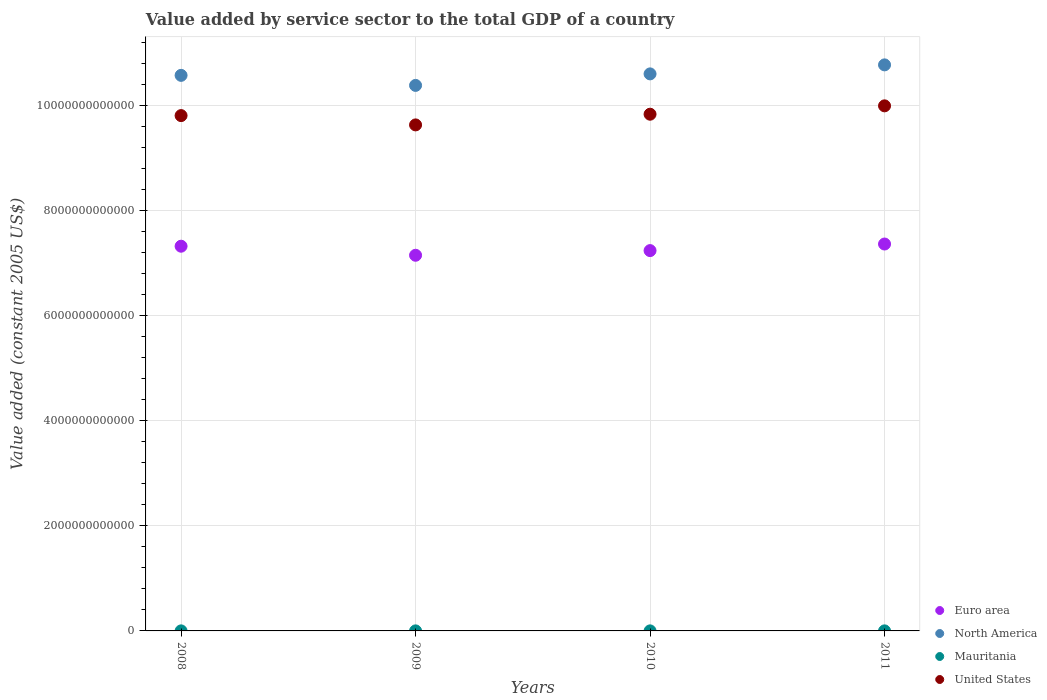What is the value added by service sector in Mauritania in 2010?
Keep it short and to the point. 9.63e+08. Across all years, what is the maximum value added by service sector in United States?
Make the answer very short. 1.00e+13. Across all years, what is the minimum value added by service sector in Euro area?
Offer a very short reply. 7.15e+12. In which year was the value added by service sector in United States maximum?
Your response must be concise. 2011. What is the total value added by service sector in North America in the graph?
Give a very brief answer. 4.23e+13. What is the difference between the value added by service sector in Mauritania in 2008 and that in 2009?
Ensure brevity in your answer.  -5.03e+06. What is the difference between the value added by service sector in Mauritania in 2011 and the value added by service sector in United States in 2009?
Provide a short and direct response. -9.63e+12. What is the average value added by service sector in United States per year?
Provide a succinct answer. 9.82e+12. In the year 2008, what is the difference between the value added by service sector in Mauritania and value added by service sector in North America?
Offer a terse response. -1.06e+13. What is the ratio of the value added by service sector in North America in 2008 to that in 2011?
Give a very brief answer. 0.98. Is the value added by service sector in North America in 2008 less than that in 2009?
Provide a short and direct response. No. What is the difference between the highest and the second highest value added by service sector in Mauritania?
Make the answer very short. 5.58e+07. What is the difference between the highest and the lowest value added by service sector in United States?
Give a very brief answer. 3.63e+11. Is it the case that in every year, the sum of the value added by service sector in North America and value added by service sector in Mauritania  is greater than the value added by service sector in Euro area?
Give a very brief answer. Yes. Is the value added by service sector in Mauritania strictly less than the value added by service sector in United States over the years?
Offer a terse response. Yes. What is the difference between two consecutive major ticks on the Y-axis?
Provide a succinct answer. 2.00e+12. Does the graph contain any zero values?
Offer a very short reply. No. Does the graph contain grids?
Your answer should be very brief. Yes. Where does the legend appear in the graph?
Make the answer very short. Bottom right. How many legend labels are there?
Your answer should be very brief. 4. What is the title of the graph?
Your response must be concise. Value added by service sector to the total GDP of a country. What is the label or title of the Y-axis?
Offer a terse response. Value added (constant 2005 US$). What is the Value added (constant 2005 US$) in Euro area in 2008?
Your answer should be very brief. 7.32e+12. What is the Value added (constant 2005 US$) in North America in 2008?
Ensure brevity in your answer.  1.06e+13. What is the Value added (constant 2005 US$) of Mauritania in 2008?
Offer a terse response. 9.01e+08. What is the Value added (constant 2005 US$) in United States in 2008?
Give a very brief answer. 9.81e+12. What is the Value added (constant 2005 US$) of Euro area in 2009?
Ensure brevity in your answer.  7.15e+12. What is the Value added (constant 2005 US$) of North America in 2009?
Your answer should be compact. 1.04e+13. What is the Value added (constant 2005 US$) of Mauritania in 2009?
Your answer should be very brief. 9.06e+08. What is the Value added (constant 2005 US$) in United States in 2009?
Provide a short and direct response. 9.63e+12. What is the Value added (constant 2005 US$) in Euro area in 2010?
Your response must be concise. 7.24e+12. What is the Value added (constant 2005 US$) of North America in 2010?
Offer a very short reply. 1.06e+13. What is the Value added (constant 2005 US$) in Mauritania in 2010?
Offer a terse response. 9.63e+08. What is the Value added (constant 2005 US$) of United States in 2010?
Provide a succinct answer. 9.84e+12. What is the Value added (constant 2005 US$) of Euro area in 2011?
Keep it short and to the point. 7.37e+12. What is the Value added (constant 2005 US$) of North America in 2011?
Provide a succinct answer. 1.08e+13. What is the Value added (constant 2005 US$) of Mauritania in 2011?
Offer a terse response. 1.02e+09. What is the Value added (constant 2005 US$) in United States in 2011?
Provide a short and direct response. 1.00e+13. Across all years, what is the maximum Value added (constant 2005 US$) in Euro area?
Offer a terse response. 7.37e+12. Across all years, what is the maximum Value added (constant 2005 US$) of North America?
Make the answer very short. 1.08e+13. Across all years, what is the maximum Value added (constant 2005 US$) in Mauritania?
Provide a succinct answer. 1.02e+09. Across all years, what is the maximum Value added (constant 2005 US$) in United States?
Make the answer very short. 1.00e+13. Across all years, what is the minimum Value added (constant 2005 US$) in Euro area?
Your answer should be very brief. 7.15e+12. Across all years, what is the minimum Value added (constant 2005 US$) in North America?
Your answer should be compact. 1.04e+13. Across all years, what is the minimum Value added (constant 2005 US$) in Mauritania?
Your response must be concise. 9.01e+08. Across all years, what is the minimum Value added (constant 2005 US$) of United States?
Offer a terse response. 9.63e+12. What is the total Value added (constant 2005 US$) in Euro area in the graph?
Your response must be concise. 2.91e+13. What is the total Value added (constant 2005 US$) in North America in the graph?
Your answer should be very brief. 4.23e+13. What is the total Value added (constant 2005 US$) in Mauritania in the graph?
Your answer should be very brief. 3.79e+09. What is the total Value added (constant 2005 US$) of United States in the graph?
Provide a succinct answer. 3.93e+13. What is the difference between the Value added (constant 2005 US$) of Euro area in 2008 and that in 2009?
Provide a short and direct response. 1.72e+11. What is the difference between the Value added (constant 2005 US$) of North America in 2008 and that in 2009?
Give a very brief answer. 1.91e+11. What is the difference between the Value added (constant 2005 US$) of Mauritania in 2008 and that in 2009?
Give a very brief answer. -5.03e+06. What is the difference between the Value added (constant 2005 US$) of United States in 2008 and that in 2009?
Ensure brevity in your answer.  1.77e+11. What is the difference between the Value added (constant 2005 US$) of Euro area in 2008 and that in 2010?
Ensure brevity in your answer.  8.37e+1. What is the difference between the Value added (constant 2005 US$) of North America in 2008 and that in 2010?
Ensure brevity in your answer.  -2.81e+1. What is the difference between the Value added (constant 2005 US$) in Mauritania in 2008 and that in 2010?
Give a very brief answer. -6.13e+07. What is the difference between the Value added (constant 2005 US$) in United States in 2008 and that in 2010?
Provide a short and direct response. -2.64e+1. What is the difference between the Value added (constant 2005 US$) of Euro area in 2008 and that in 2011?
Keep it short and to the point. -4.16e+1. What is the difference between the Value added (constant 2005 US$) in North America in 2008 and that in 2011?
Your answer should be compact. -2.00e+11. What is the difference between the Value added (constant 2005 US$) in Mauritania in 2008 and that in 2011?
Your answer should be very brief. -1.17e+08. What is the difference between the Value added (constant 2005 US$) of United States in 2008 and that in 2011?
Offer a terse response. -1.86e+11. What is the difference between the Value added (constant 2005 US$) in Euro area in 2009 and that in 2010?
Your answer should be compact. -8.87e+1. What is the difference between the Value added (constant 2005 US$) of North America in 2009 and that in 2010?
Provide a succinct answer. -2.19e+11. What is the difference between the Value added (constant 2005 US$) in Mauritania in 2009 and that in 2010?
Offer a very short reply. -5.63e+07. What is the difference between the Value added (constant 2005 US$) of United States in 2009 and that in 2010?
Offer a terse response. -2.04e+11. What is the difference between the Value added (constant 2005 US$) in Euro area in 2009 and that in 2011?
Keep it short and to the point. -2.14e+11. What is the difference between the Value added (constant 2005 US$) of North America in 2009 and that in 2011?
Your answer should be compact. -3.91e+11. What is the difference between the Value added (constant 2005 US$) of Mauritania in 2009 and that in 2011?
Keep it short and to the point. -1.12e+08. What is the difference between the Value added (constant 2005 US$) in United States in 2009 and that in 2011?
Make the answer very short. -3.63e+11. What is the difference between the Value added (constant 2005 US$) of Euro area in 2010 and that in 2011?
Give a very brief answer. -1.25e+11. What is the difference between the Value added (constant 2005 US$) of North America in 2010 and that in 2011?
Your answer should be compact. -1.72e+11. What is the difference between the Value added (constant 2005 US$) of Mauritania in 2010 and that in 2011?
Give a very brief answer. -5.58e+07. What is the difference between the Value added (constant 2005 US$) in United States in 2010 and that in 2011?
Ensure brevity in your answer.  -1.59e+11. What is the difference between the Value added (constant 2005 US$) in Euro area in 2008 and the Value added (constant 2005 US$) in North America in 2009?
Ensure brevity in your answer.  -3.06e+12. What is the difference between the Value added (constant 2005 US$) of Euro area in 2008 and the Value added (constant 2005 US$) of Mauritania in 2009?
Offer a very short reply. 7.32e+12. What is the difference between the Value added (constant 2005 US$) in Euro area in 2008 and the Value added (constant 2005 US$) in United States in 2009?
Give a very brief answer. -2.31e+12. What is the difference between the Value added (constant 2005 US$) of North America in 2008 and the Value added (constant 2005 US$) of Mauritania in 2009?
Provide a succinct answer. 1.06e+13. What is the difference between the Value added (constant 2005 US$) of North America in 2008 and the Value added (constant 2005 US$) of United States in 2009?
Your answer should be very brief. 9.43e+11. What is the difference between the Value added (constant 2005 US$) of Mauritania in 2008 and the Value added (constant 2005 US$) of United States in 2009?
Your answer should be compact. -9.63e+12. What is the difference between the Value added (constant 2005 US$) in Euro area in 2008 and the Value added (constant 2005 US$) in North America in 2010?
Provide a short and direct response. -3.28e+12. What is the difference between the Value added (constant 2005 US$) of Euro area in 2008 and the Value added (constant 2005 US$) of Mauritania in 2010?
Provide a short and direct response. 7.32e+12. What is the difference between the Value added (constant 2005 US$) in Euro area in 2008 and the Value added (constant 2005 US$) in United States in 2010?
Give a very brief answer. -2.51e+12. What is the difference between the Value added (constant 2005 US$) in North America in 2008 and the Value added (constant 2005 US$) in Mauritania in 2010?
Your answer should be very brief. 1.06e+13. What is the difference between the Value added (constant 2005 US$) of North America in 2008 and the Value added (constant 2005 US$) of United States in 2010?
Give a very brief answer. 7.40e+11. What is the difference between the Value added (constant 2005 US$) of Mauritania in 2008 and the Value added (constant 2005 US$) of United States in 2010?
Make the answer very short. -9.84e+12. What is the difference between the Value added (constant 2005 US$) of Euro area in 2008 and the Value added (constant 2005 US$) of North America in 2011?
Make the answer very short. -3.45e+12. What is the difference between the Value added (constant 2005 US$) in Euro area in 2008 and the Value added (constant 2005 US$) in Mauritania in 2011?
Your answer should be very brief. 7.32e+12. What is the difference between the Value added (constant 2005 US$) of Euro area in 2008 and the Value added (constant 2005 US$) of United States in 2011?
Offer a terse response. -2.67e+12. What is the difference between the Value added (constant 2005 US$) of North America in 2008 and the Value added (constant 2005 US$) of Mauritania in 2011?
Offer a very short reply. 1.06e+13. What is the difference between the Value added (constant 2005 US$) in North America in 2008 and the Value added (constant 2005 US$) in United States in 2011?
Make the answer very short. 5.80e+11. What is the difference between the Value added (constant 2005 US$) in Mauritania in 2008 and the Value added (constant 2005 US$) in United States in 2011?
Your answer should be very brief. -1.00e+13. What is the difference between the Value added (constant 2005 US$) in Euro area in 2009 and the Value added (constant 2005 US$) in North America in 2010?
Give a very brief answer. -3.45e+12. What is the difference between the Value added (constant 2005 US$) in Euro area in 2009 and the Value added (constant 2005 US$) in Mauritania in 2010?
Your answer should be very brief. 7.15e+12. What is the difference between the Value added (constant 2005 US$) of Euro area in 2009 and the Value added (constant 2005 US$) of United States in 2010?
Keep it short and to the point. -2.69e+12. What is the difference between the Value added (constant 2005 US$) of North America in 2009 and the Value added (constant 2005 US$) of Mauritania in 2010?
Provide a short and direct response. 1.04e+13. What is the difference between the Value added (constant 2005 US$) of North America in 2009 and the Value added (constant 2005 US$) of United States in 2010?
Your answer should be very brief. 5.49e+11. What is the difference between the Value added (constant 2005 US$) in Mauritania in 2009 and the Value added (constant 2005 US$) in United States in 2010?
Make the answer very short. -9.84e+12. What is the difference between the Value added (constant 2005 US$) of Euro area in 2009 and the Value added (constant 2005 US$) of North America in 2011?
Make the answer very short. -3.62e+12. What is the difference between the Value added (constant 2005 US$) of Euro area in 2009 and the Value added (constant 2005 US$) of Mauritania in 2011?
Give a very brief answer. 7.15e+12. What is the difference between the Value added (constant 2005 US$) in Euro area in 2009 and the Value added (constant 2005 US$) in United States in 2011?
Your response must be concise. -2.84e+12. What is the difference between the Value added (constant 2005 US$) in North America in 2009 and the Value added (constant 2005 US$) in Mauritania in 2011?
Give a very brief answer. 1.04e+13. What is the difference between the Value added (constant 2005 US$) in North America in 2009 and the Value added (constant 2005 US$) in United States in 2011?
Provide a succinct answer. 3.89e+11. What is the difference between the Value added (constant 2005 US$) of Mauritania in 2009 and the Value added (constant 2005 US$) of United States in 2011?
Your answer should be compact. -1.00e+13. What is the difference between the Value added (constant 2005 US$) in Euro area in 2010 and the Value added (constant 2005 US$) in North America in 2011?
Provide a succinct answer. -3.54e+12. What is the difference between the Value added (constant 2005 US$) of Euro area in 2010 and the Value added (constant 2005 US$) of Mauritania in 2011?
Give a very brief answer. 7.24e+12. What is the difference between the Value added (constant 2005 US$) of Euro area in 2010 and the Value added (constant 2005 US$) of United States in 2011?
Ensure brevity in your answer.  -2.76e+12. What is the difference between the Value added (constant 2005 US$) in North America in 2010 and the Value added (constant 2005 US$) in Mauritania in 2011?
Offer a very short reply. 1.06e+13. What is the difference between the Value added (constant 2005 US$) in North America in 2010 and the Value added (constant 2005 US$) in United States in 2011?
Provide a succinct answer. 6.08e+11. What is the difference between the Value added (constant 2005 US$) of Mauritania in 2010 and the Value added (constant 2005 US$) of United States in 2011?
Provide a succinct answer. -1.00e+13. What is the average Value added (constant 2005 US$) in Euro area per year?
Offer a very short reply. 7.27e+12. What is the average Value added (constant 2005 US$) in North America per year?
Keep it short and to the point. 1.06e+13. What is the average Value added (constant 2005 US$) in Mauritania per year?
Offer a terse response. 9.47e+08. What is the average Value added (constant 2005 US$) in United States per year?
Give a very brief answer. 9.82e+12. In the year 2008, what is the difference between the Value added (constant 2005 US$) in Euro area and Value added (constant 2005 US$) in North America?
Make the answer very short. -3.25e+12. In the year 2008, what is the difference between the Value added (constant 2005 US$) of Euro area and Value added (constant 2005 US$) of Mauritania?
Provide a short and direct response. 7.32e+12. In the year 2008, what is the difference between the Value added (constant 2005 US$) in Euro area and Value added (constant 2005 US$) in United States?
Offer a terse response. -2.49e+12. In the year 2008, what is the difference between the Value added (constant 2005 US$) in North America and Value added (constant 2005 US$) in Mauritania?
Provide a short and direct response. 1.06e+13. In the year 2008, what is the difference between the Value added (constant 2005 US$) of North America and Value added (constant 2005 US$) of United States?
Provide a short and direct response. 7.66e+11. In the year 2008, what is the difference between the Value added (constant 2005 US$) in Mauritania and Value added (constant 2005 US$) in United States?
Provide a succinct answer. -9.81e+12. In the year 2009, what is the difference between the Value added (constant 2005 US$) of Euro area and Value added (constant 2005 US$) of North America?
Give a very brief answer. -3.23e+12. In the year 2009, what is the difference between the Value added (constant 2005 US$) in Euro area and Value added (constant 2005 US$) in Mauritania?
Your response must be concise. 7.15e+12. In the year 2009, what is the difference between the Value added (constant 2005 US$) in Euro area and Value added (constant 2005 US$) in United States?
Your answer should be compact. -2.48e+12. In the year 2009, what is the difference between the Value added (constant 2005 US$) in North America and Value added (constant 2005 US$) in Mauritania?
Offer a very short reply. 1.04e+13. In the year 2009, what is the difference between the Value added (constant 2005 US$) of North America and Value added (constant 2005 US$) of United States?
Offer a very short reply. 7.52e+11. In the year 2009, what is the difference between the Value added (constant 2005 US$) in Mauritania and Value added (constant 2005 US$) in United States?
Your response must be concise. -9.63e+12. In the year 2010, what is the difference between the Value added (constant 2005 US$) in Euro area and Value added (constant 2005 US$) in North America?
Your answer should be very brief. -3.36e+12. In the year 2010, what is the difference between the Value added (constant 2005 US$) of Euro area and Value added (constant 2005 US$) of Mauritania?
Your answer should be very brief. 7.24e+12. In the year 2010, what is the difference between the Value added (constant 2005 US$) in Euro area and Value added (constant 2005 US$) in United States?
Offer a very short reply. -2.60e+12. In the year 2010, what is the difference between the Value added (constant 2005 US$) in North America and Value added (constant 2005 US$) in Mauritania?
Your answer should be compact. 1.06e+13. In the year 2010, what is the difference between the Value added (constant 2005 US$) in North America and Value added (constant 2005 US$) in United States?
Provide a succinct answer. 7.68e+11. In the year 2010, what is the difference between the Value added (constant 2005 US$) in Mauritania and Value added (constant 2005 US$) in United States?
Give a very brief answer. -9.84e+12. In the year 2011, what is the difference between the Value added (constant 2005 US$) of Euro area and Value added (constant 2005 US$) of North America?
Offer a very short reply. -3.41e+12. In the year 2011, what is the difference between the Value added (constant 2005 US$) in Euro area and Value added (constant 2005 US$) in Mauritania?
Ensure brevity in your answer.  7.37e+12. In the year 2011, what is the difference between the Value added (constant 2005 US$) in Euro area and Value added (constant 2005 US$) in United States?
Provide a succinct answer. -2.63e+12. In the year 2011, what is the difference between the Value added (constant 2005 US$) of North America and Value added (constant 2005 US$) of Mauritania?
Offer a terse response. 1.08e+13. In the year 2011, what is the difference between the Value added (constant 2005 US$) of North America and Value added (constant 2005 US$) of United States?
Offer a terse response. 7.80e+11. In the year 2011, what is the difference between the Value added (constant 2005 US$) of Mauritania and Value added (constant 2005 US$) of United States?
Your answer should be compact. -1.00e+13. What is the ratio of the Value added (constant 2005 US$) of Euro area in 2008 to that in 2009?
Offer a very short reply. 1.02. What is the ratio of the Value added (constant 2005 US$) in North America in 2008 to that in 2009?
Make the answer very short. 1.02. What is the ratio of the Value added (constant 2005 US$) of Mauritania in 2008 to that in 2009?
Offer a very short reply. 0.99. What is the ratio of the Value added (constant 2005 US$) of United States in 2008 to that in 2009?
Offer a terse response. 1.02. What is the ratio of the Value added (constant 2005 US$) of Euro area in 2008 to that in 2010?
Offer a terse response. 1.01. What is the ratio of the Value added (constant 2005 US$) of North America in 2008 to that in 2010?
Give a very brief answer. 1. What is the ratio of the Value added (constant 2005 US$) in Mauritania in 2008 to that in 2010?
Your answer should be compact. 0.94. What is the ratio of the Value added (constant 2005 US$) of Euro area in 2008 to that in 2011?
Give a very brief answer. 0.99. What is the ratio of the Value added (constant 2005 US$) in North America in 2008 to that in 2011?
Your response must be concise. 0.98. What is the ratio of the Value added (constant 2005 US$) of Mauritania in 2008 to that in 2011?
Ensure brevity in your answer.  0.89. What is the ratio of the Value added (constant 2005 US$) in United States in 2008 to that in 2011?
Keep it short and to the point. 0.98. What is the ratio of the Value added (constant 2005 US$) of Euro area in 2009 to that in 2010?
Give a very brief answer. 0.99. What is the ratio of the Value added (constant 2005 US$) in North America in 2009 to that in 2010?
Ensure brevity in your answer.  0.98. What is the ratio of the Value added (constant 2005 US$) in Mauritania in 2009 to that in 2010?
Give a very brief answer. 0.94. What is the ratio of the Value added (constant 2005 US$) of United States in 2009 to that in 2010?
Keep it short and to the point. 0.98. What is the ratio of the Value added (constant 2005 US$) in Euro area in 2009 to that in 2011?
Keep it short and to the point. 0.97. What is the ratio of the Value added (constant 2005 US$) in North America in 2009 to that in 2011?
Your response must be concise. 0.96. What is the ratio of the Value added (constant 2005 US$) in Mauritania in 2009 to that in 2011?
Your response must be concise. 0.89. What is the ratio of the Value added (constant 2005 US$) in United States in 2009 to that in 2011?
Keep it short and to the point. 0.96. What is the ratio of the Value added (constant 2005 US$) of North America in 2010 to that in 2011?
Your response must be concise. 0.98. What is the ratio of the Value added (constant 2005 US$) in Mauritania in 2010 to that in 2011?
Your answer should be very brief. 0.95. What is the ratio of the Value added (constant 2005 US$) of United States in 2010 to that in 2011?
Your answer should be very brief. 0.98. What is the difference between the highest and the second highest Value added (constant 2005 US$) of Euro area?
Give a very brief answer. 4.16e+1. What is the difference between the highest and the second highest Value added (constant 2005 US$) of North America?
Offer a terse response. 1.72e+11. What is the difference between the highest and the second highest Value added (constant 2005 US$) in Mauritania?
Keep it short and to the point. 5.58e+07. What is the difference between the highest and the second highest Value added (constant 2005 US$) in United States?
Offer a terse response. 1.59e+11. What is the difference between the highest and the lowest Value added (constant 2005 US$) in Euro area?
Offer a terse response. 2.14e+11. What is the difference between the highest and the lowest Value added (constant 2005 US$) of North America?
Your answer should be compact. 3.91e+11. What is the difference between the highest and the lowest Value added (constant 2005 US$) in Mauritania?
Make the answer very short. 1.17e+08. What is the difference between the highest and the lowest Value added (constant 2005 US$) of United States?
Provide a succinct answer. 3.63e+11. 